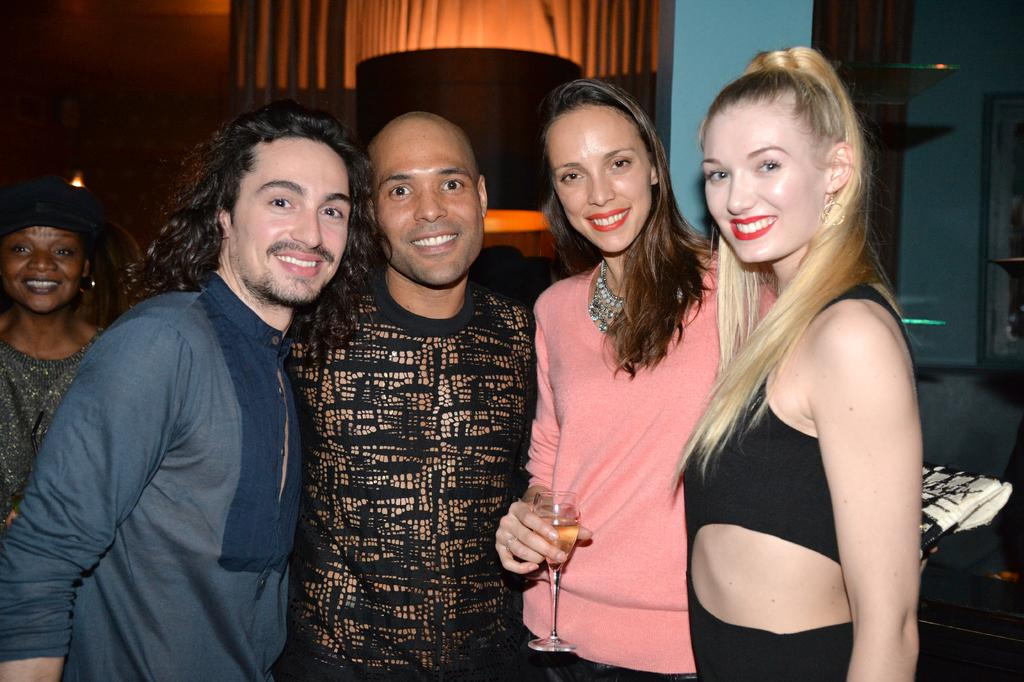How many people are in the image? There are five people in the image. Can you describe the gender distribution of the people in the image? Three of them are women, and two of them are men. What is the facial expression of the people in the image? All of the people are smiling. What type of marble is visible in the image? There is no marble present in the image. What is the reason for the people in the image to be smiling? The image does not provide any information about the reason for the people's smiles. 